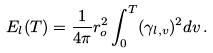<formula> <loc_0><loc_0><loc_500><loc_500>E _ { l } ( T ) = \frac { 1 } { 4 \pi } r ^ { 2 } _ { o } \int ^ { T } _ { 0 } ( \gamma _ { l , v } ) ^ { 2 } d v \, .</formula> 